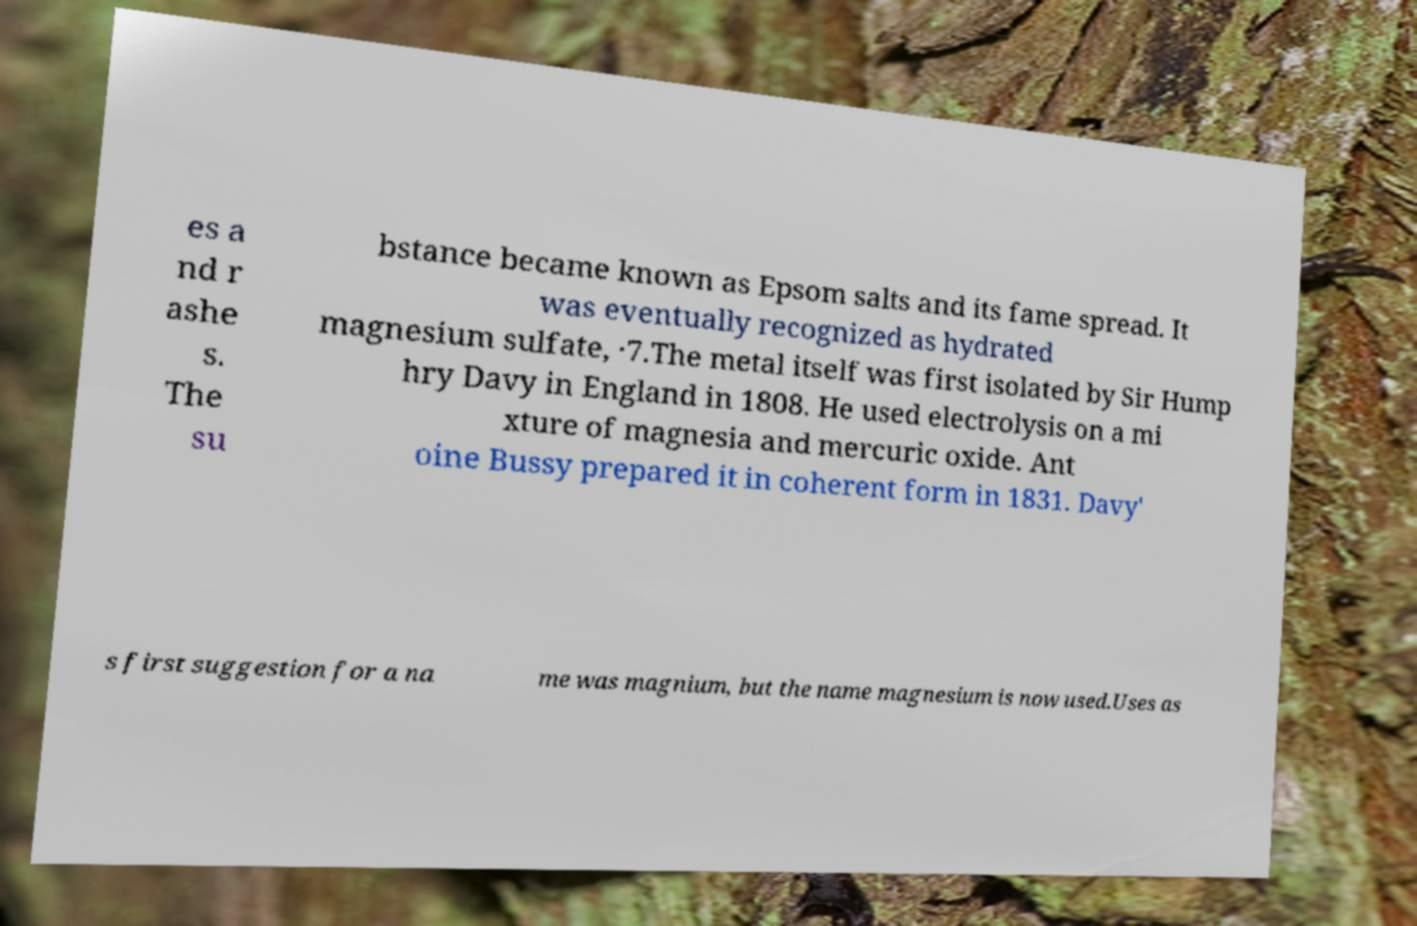There's text embedded in this image that I need extracted. Can you transcribe it verbatim? es a nd r ashe s. The su bstance became known as Epsom salts and its fame spread. It was eventually recognized as hydrated magnesium sulfate, ·7.The metal itself was first isolated by Sir Hump hry Davy in England in 1808. He used electrolysis on a mi xture of magnesia and mercuric oxide. Ant oine Bussy prepared it in coherent form in 1831. Davy' s first suggestion for a na me was magnium, but the name magnesium is now used.Uses as 